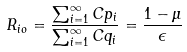Convert formula to latex. <formula><loc_0><loc_0><loc_500><loc_500>R _ { i o } = \frac { \sum _ { i = 1 } ^ { \infty } C p _ { i } } { \sum _ { i = 1 } ^ { \infty } C q _ { i } } = \frac { 1 - \mu } { \epsilon }</formula> 